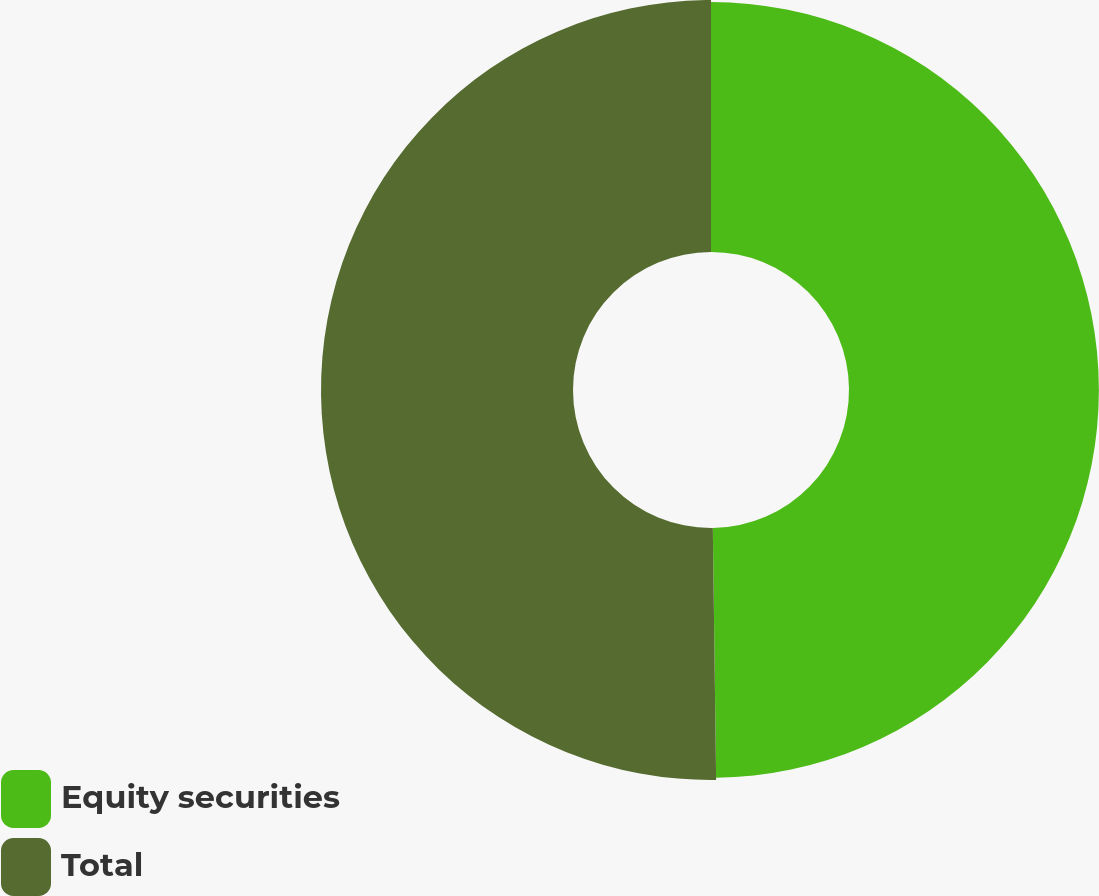Convert chart to OTSL. <chart><loc_0><loc_0><loc_500><loc_500><pie_chart><fcel>Equity securities<fcel>Total<nl><fcel>49.79%<fcel>50.21%<nl></chart> 